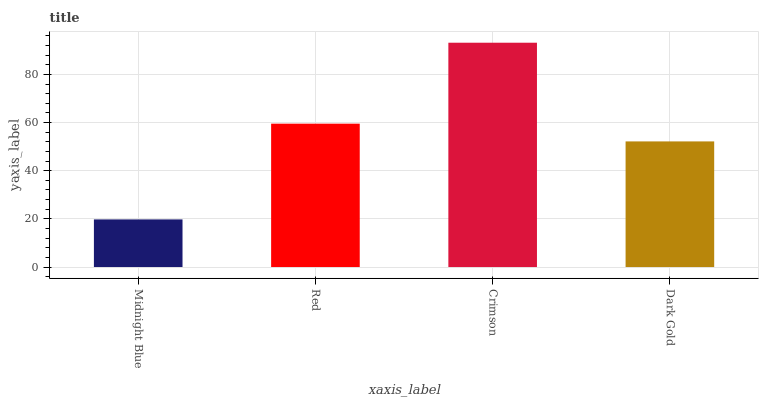Is Midnight Blue the minimum?
Answer yes or no. Yes. Is Crimson the maximum?
Answer yes or no. Yes. Is Red the minimum?
Answer yes or no. No. Is Red the maximum?
Answer yes or no. No. Is Red greater than Midnight Blue?
Answer yes or no. Yes. Is Midnight Blue less than Red?
Answer yes or no. Yes. Is Midnight Blue greater than Red?
Answer yes or no. No. Is Red less than Midnight Blue?
Answer yes or no. No. Is Red the high median?
Answer yes or no. Yes. Is Dark Gold the low median?
Answer yes or no. Yes. Is Crimson the high median?
Answer yes or no. No. Is Red the low median?
Answer yes or no. No. 